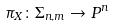Convert formula to latex. <formula><loc_0><loc_0><loc_500><loc_500>\pi _ { X } \colon \Sigma _ { n , m } \rightarrow P ^ { n }</formula> 